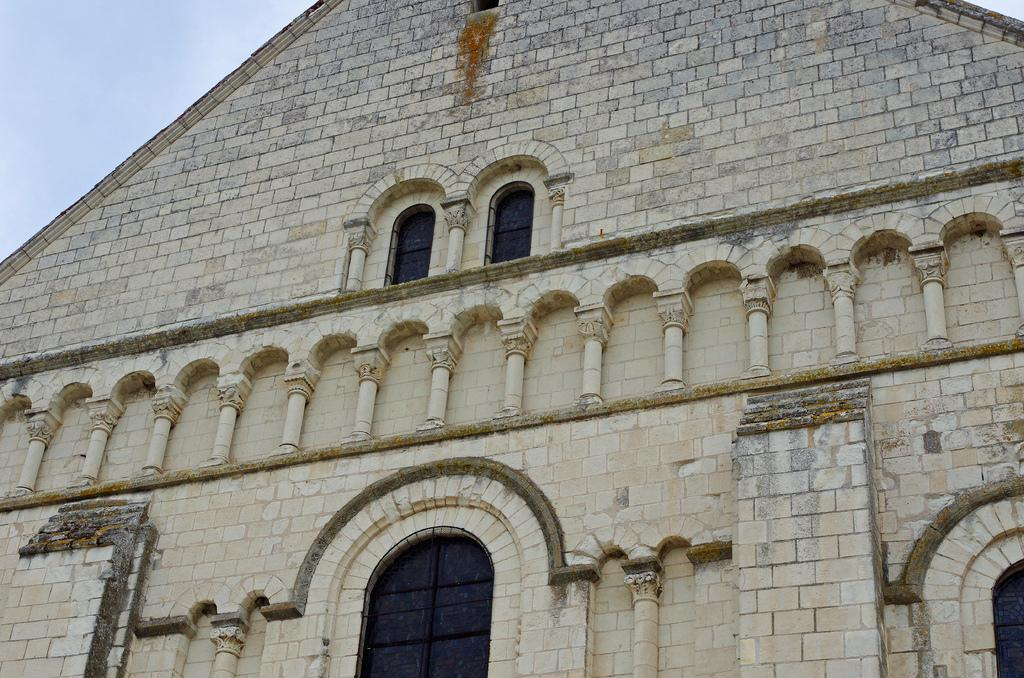What type of structure is present in the image? There is a building in the image. What architectural features can be seen on the building? The building has pillars and windows. What is visible at the top of the image? The sky is visible at the top of the image. What effect does the building have on the front of the image? There is no specific effect mentioned in the facts, and the term "front" is not relevant to the image. The building is simply present in the image, and its architectural features are described. 